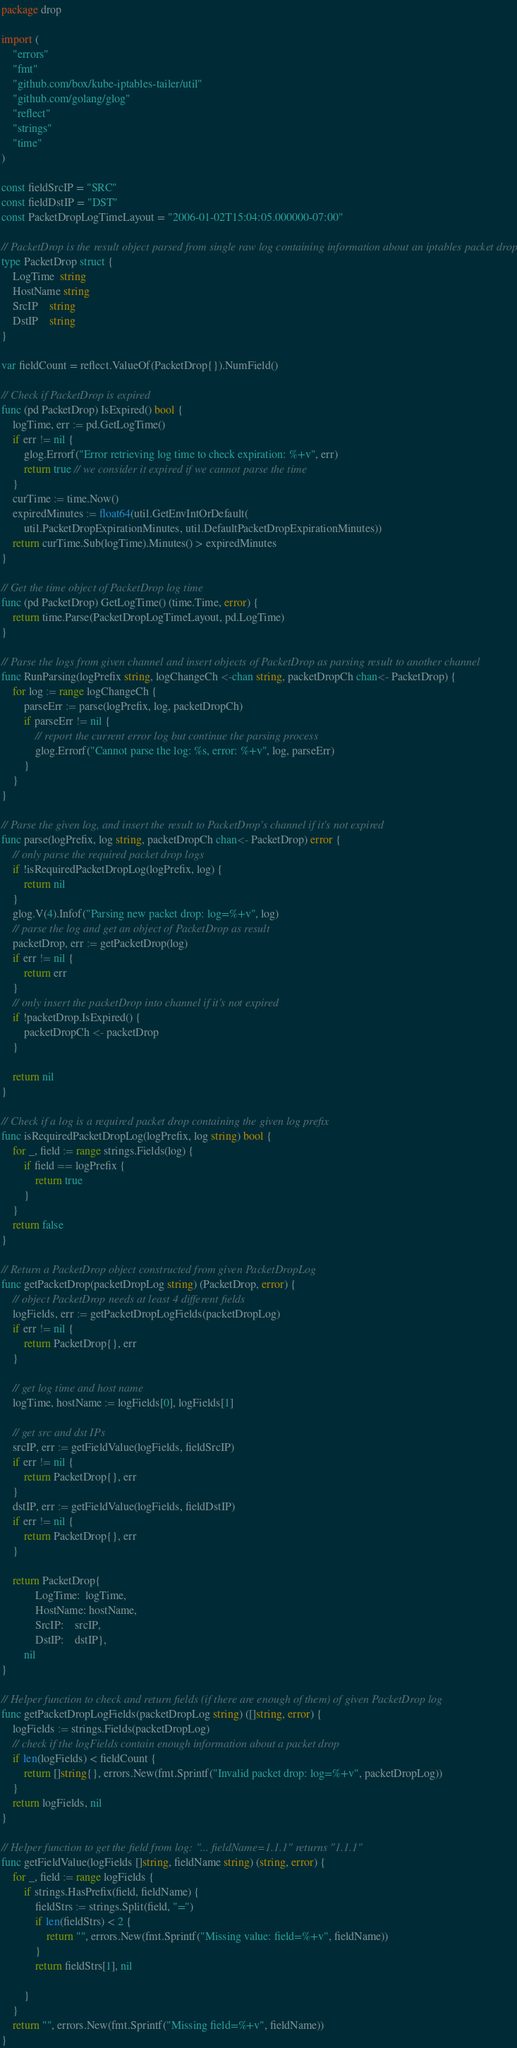<code> <loc_0><loc_0><loc_500><loc_500><_Go_>package drop

import (
	"errors"
	"fmt"
	"github.com/box/kube-iptables-tailer/util"
	"github.com/golang/glog"
	"reflect"
	"strings"
	"time"
)

const fieldSrcIP = "SRC"
const fieldDstIP = "DST"
const PacketDropLogTimeLayout = "2006-01-02T15:04:05.000000-07:00"

// PacketDrop is the result object parsed from single raw log containing information about an iptables packet drop.
type PacketDrop struct {
	LogTime  string
	HostName string
	SrcIP    string
	DstIP    string
}

var fieldCount = reflect.ValueOf(PacketDrop{}).NumField()

// Check if PacketDrop is expired
func (pd PacketDrop) IsExpired() bool {
	logTime, err := pd.GetLogTime()
	if err != nil {
		glog.Errorf("Error retrieving log time to check expiration: %+v", err)
		return true // we consider it expired if we cannot parse the time
	}
	curTime := time.Now()
	expiredMinutes := float64(util.GetEnvIntOrDefault(
		util.PacketDropExpirationMinutes, util.DefaultPacketDropExpirationMinutes))
	return curTime.Sub(logTime).Minutes() > expiredMinutes
}

// Get the time object of PacketDrop log time
func (pd PacketDrop) GetLogTime() (time.Time, error) {
	return time.Parse(PacketDropLogTimeLayout, pd.LogTime)
}

// Parse the logs from given channel and insert objects of PacketDrop as parsing result to another channel
func RunParsing(logPrefix string, logChangeCh <-chan string, packetDropCh chan<- PacketDrop) {
	for log := range logChangeCh {
		parseErr := parse(logPrefix, log, packetDropCh)
		if parseErr != nil {
			// report the current error log but continue the parsing process
			glog.Errorf("Cannot parse the log: %s, error: %+v", log, parseErr)
		}
	}
}

// Parse the given log, and insert the result to PacketDrop's channel if it's not expired
func parse(logPrefix, log string, packetDropCh chan<- PacketDrop) error {
	// only parse the required packet drop logs
	if !isRequiredPacketDropLog(logPrefix, log) {
		return nil
	}
	glog.V(4).Infof("Parsing new packet drop: log=%+v", log)
	// parse the log and get an object of PacketDrop as result
	packetDrop, err := getPacketDrop(log)
	if err != nil {
		return err
	}
	// only insert the packetDrop into channel if it's not expired
	if !packetDrop.IsExpired() {
		packetDropCh <- packetDrop
	}

	return nil
}

// Check if a log is a required packet drop containing the given log prefix
func isRequiredPacketDropLog(logPrefix, log string) bool {
	for _, field := range strings.Fields(log) {
		if field == logPrefix {
			return true
		}
	}
	return false
}

// Return a PacketDrop object constructed from given PacketDropLog
func getPacketDrop(packetDropLog string) (PacketDrop, error) {
	// object PacketDrop needs at least 4 different fields
	logFields, err := getPacketDropLogFields(packetDropLog)
	if err != nil {
		return PacketDrop{}, err
	}

	// get log time and host name
	logTime, hostName := logFields[0], logFields[1]

	// get src and dst IPs
	srcIP, err := getFieldValue(logFields, fieldSrcIP)
	if err != nil {
		return PacketDrop{}, err
	}
	dstIP, err := getFieldValue(logFields, fieldDstIP)
	if err != nil {
		return PacketDrop{}, err
	}

	return PacketDrop{
			LogTime:  logTime,
			HostName: hostName,
			SrcIP:    srcIP,
			DstIP:    dstIP},
		nil
}

// Helper function to check and return fields (if there are enough of them) of given PacketDrop log
func getPacketDropLogFields(packetDropLog string) ([]string, error) {
	logFields := strings.Fields(packetDropLog)
	// check if the logFields contain enough information about a packet drop
	if len(logFields) < fieldCount {
		return []string{}, errors.New(fmt.Sprintf("Invalid packet drop: log=%+v", packetDropLog))
	}
	return logFields, nil
}

// Helper function to get the field from log: "... fieldName=1.1.1" returns "1.1.1"
func getFieldValue(logFields []string, fieldName string) (string, error) {
	for _, field := range logFields {
		if strings.HasPrefix(field, fieldName) {
			fieldStrs := strings.Split(field, "=")
			if len(fieldStrs) < 2 {
				return "", errors.New(fmt.Sprintf("Missing value: field=%+v", fieldName))
			}
			return fieldStrs[1], nil

		}
	}
	return "", errors.New(fmt.Sprintf("Missing field=%+v", fieldName))
}
</code> 